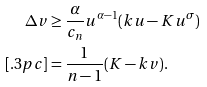<formula> <loc_0><loc_0><loc_500><loc_500>\Delta v & \geq { \frac { \alpha } { c _ { n } } } u ^ { \alpha - 1 } ( k u - K u ^ { \sigma } ) \\ [ . 3 p c ] & = { \frac { 1 } { n - 1 } } ( K - k v ) .</formula> 